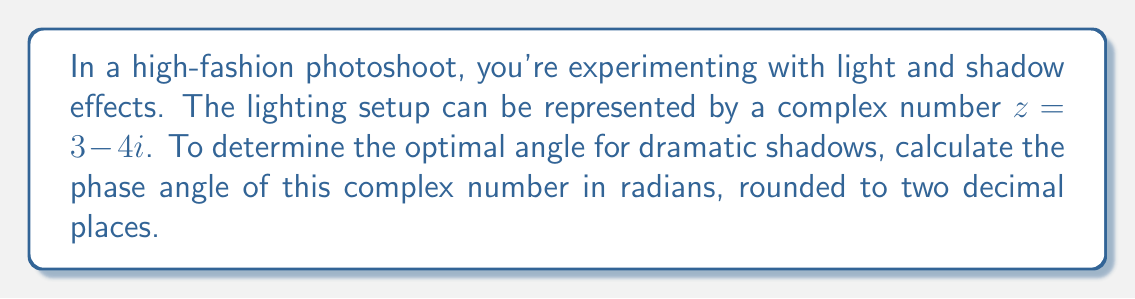Show me your answer to this math problem. To find the phase angle of a complex number $z = a + bi$, we use the arctangent function:

$$\theta = \arctan\left(\frac{b}{a}\right)$$

However, we need to be careful about which quadrant the complex number is in. For $z = 3 - 4i$:

1) Identify the real and imaginary parts:
   $a = 3$ (real part)
   $b = -4$ (imaginary part)

2) Since $a$ is positive and $b$ is negative, $z$ is in the fourth quadrant.

3) Calculate the raw angle:
   $$\theta_{raw} = \arctan\left(\frac{-4}{3}\right) = -0.9272952180$$

4) Adjust for the fourth quadrant by adding $2\pi$:
   $$\theta = -0.9272952180 + 2\pi = 5.3557520942$$

5) Round to two decimal places:
   $$\theta \approx 5.36\text{ radians}$$

This angle represents the optimal positioning for dramatic shadow effects in the photoshoot.
Answer: $5.36$ radians 